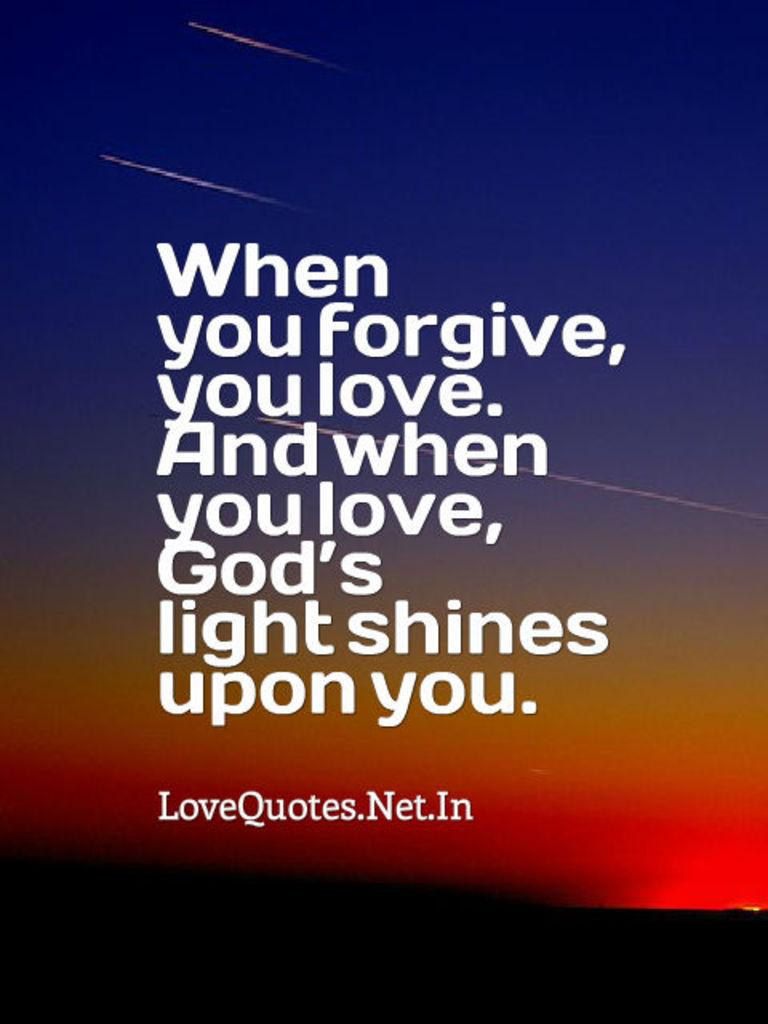<image>
Summarize the visual content of the image. A quote about forgiveness and love from LoveQuotes.Net.In. 